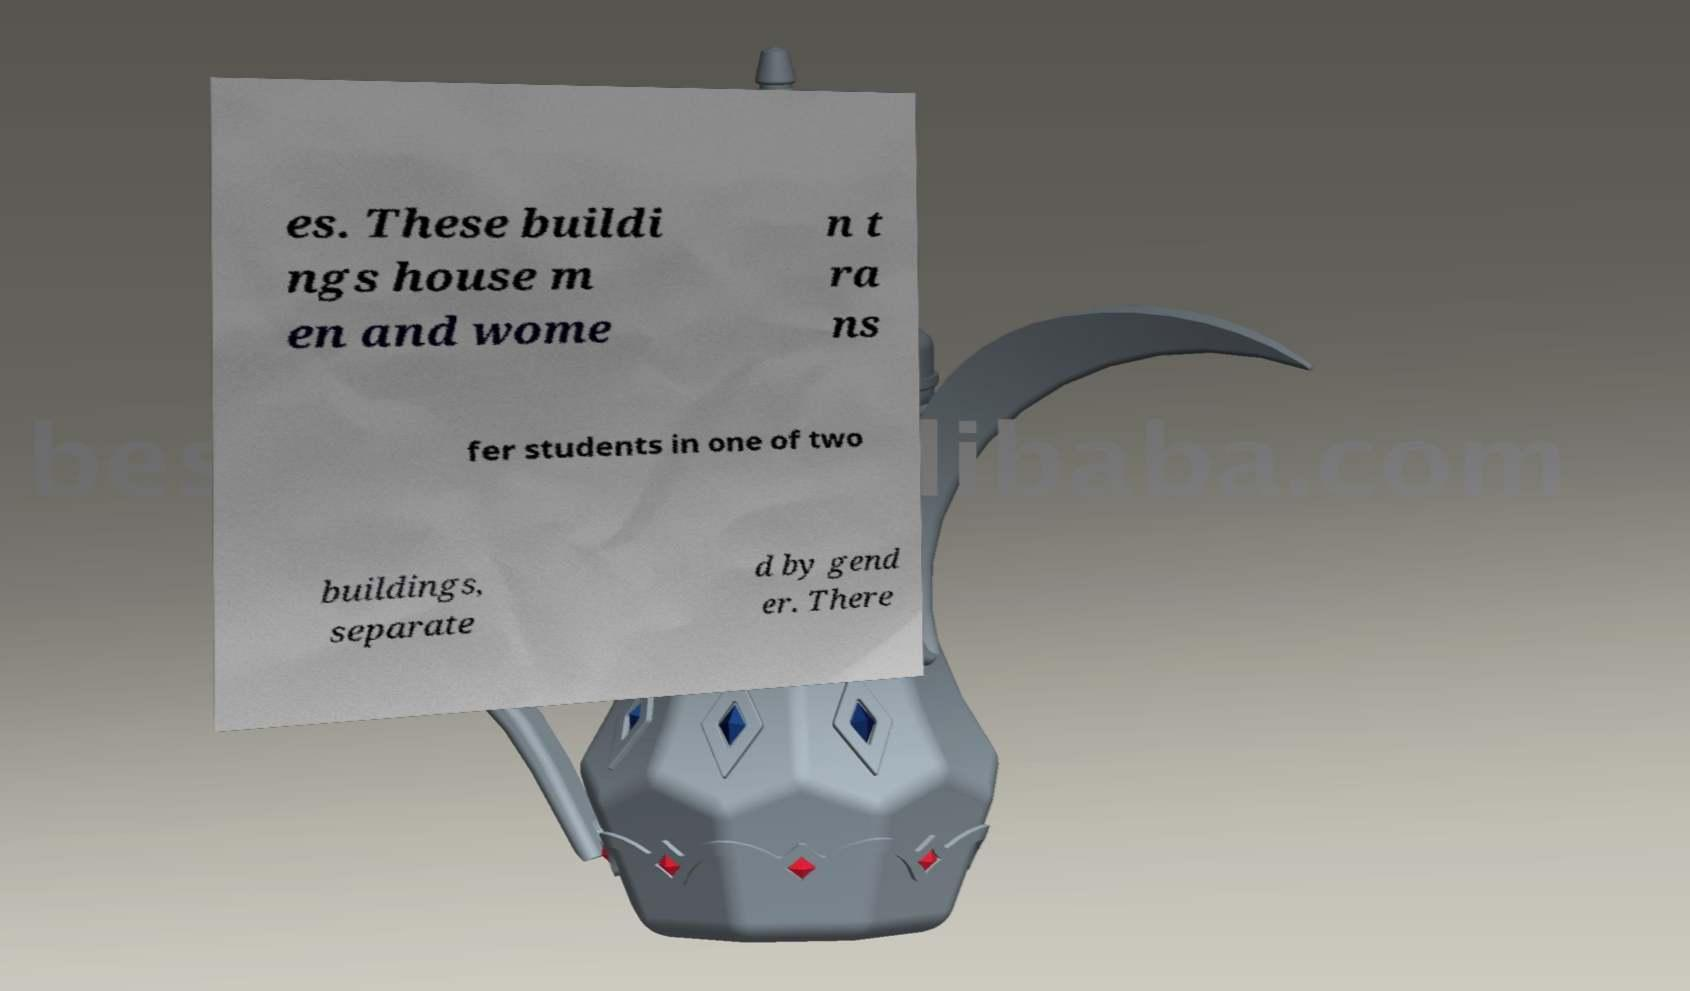I need the written content from this picture converted into text. Can you do that? es. These buildi ngs house m en and wome n t ra ns fer students in one of two buildings, separate d by gend er. There 